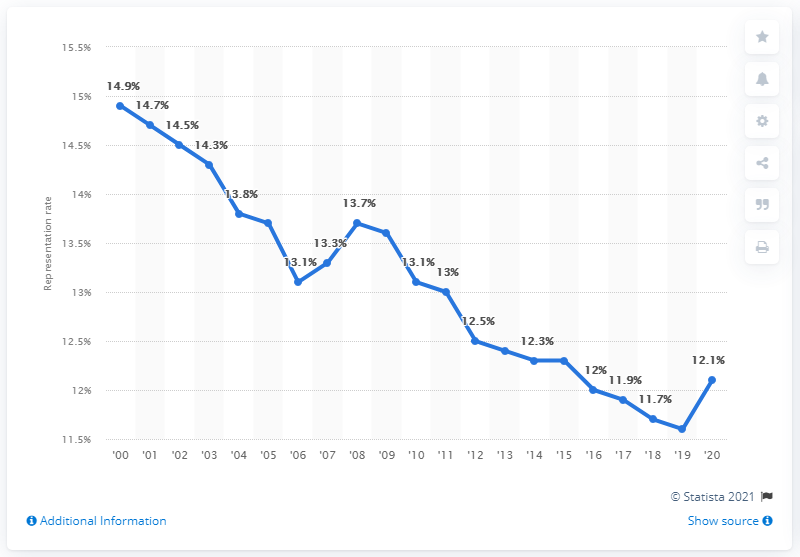Give some essential details in this illustration. In 2020, approximately 12.1% of employees were represented by unions. 